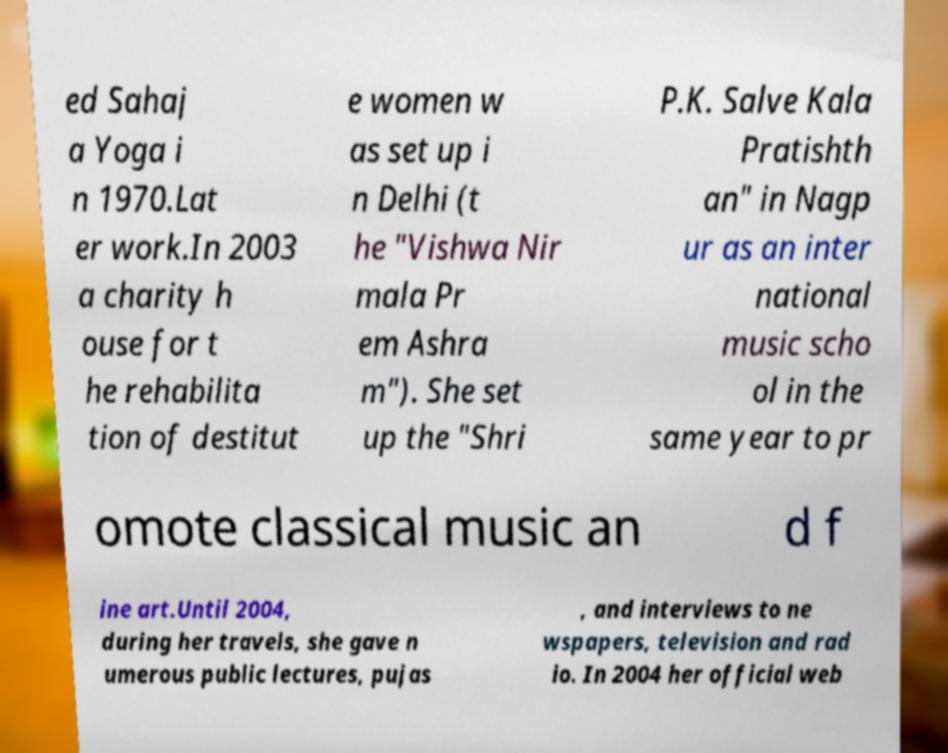For documentation purposes, I need the text within this image transcribed. Could you provide that? ed Sahaj a Yoga i n 1970.Lat er work.In 2003 a charity h ouse for t he rehabilita tion of destitut e women w as set up i n Delhi (t he "Vishwa Nir mala Pr em Ashra m"). She set up the "Shri P.K. Salve Kala Pratishth an" in Nagp ur as an inter national music scho ol in the same year to pr omote classical music an d f ine art.Until 2004, during her travels, she gave n umerous public lectures, pujas , and interviews to ne wspapers, television and rad io. In 2004 her official web 